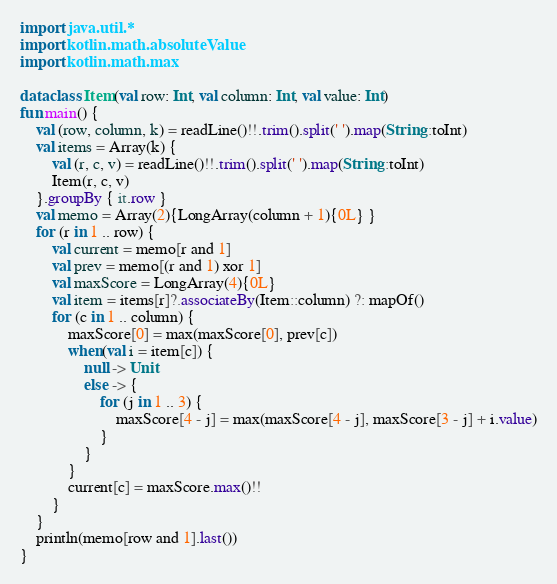Convert code to text. <code><loc_0><loc_0><loc_500><loc_500><_Kotlin_>import java.util.*
import kotlin.math.absoluteValue
import kotlin.math.max

data class Item(val row: Int, val column: Int, val value: Int)
fun main() {
    val (row, column, k) = readLine()!!.trim().split(' ').map(String::toInt)
    val items = Array(k) {
        val (r, c, v) = readLine()!!.trim().split(' ').map(String::toInt)
        Item(r, c, v)
    }.groupBy { it.row }
    val memo = Array(2){LongArray(column + 1){0L} }
    for (r in 1 .. row) {
        val current = memo[r and 1]
        val prev = memo[(r and 1) xor 1]
        val maxScore = LongArray(4){0L}
        val item = items[r]?.associateBy(Item::column) ?: mapOf()
        for (c in 1 .. column) {
            maxScore[0] = max(maxScore[0], prev[c])
            when(val i = item[c]) {
                null -> Unit
                else -> {
                    for (j in 1 .. 3) {
                        maxScore[4 - j] = max(maxScore[4 - j], maxScore[3 - j] + i.value)
                    }
                }
            }
            current[c] = maxScore.max()!!
        }
    }
    println(memo[row and 1].last())
}</code> 